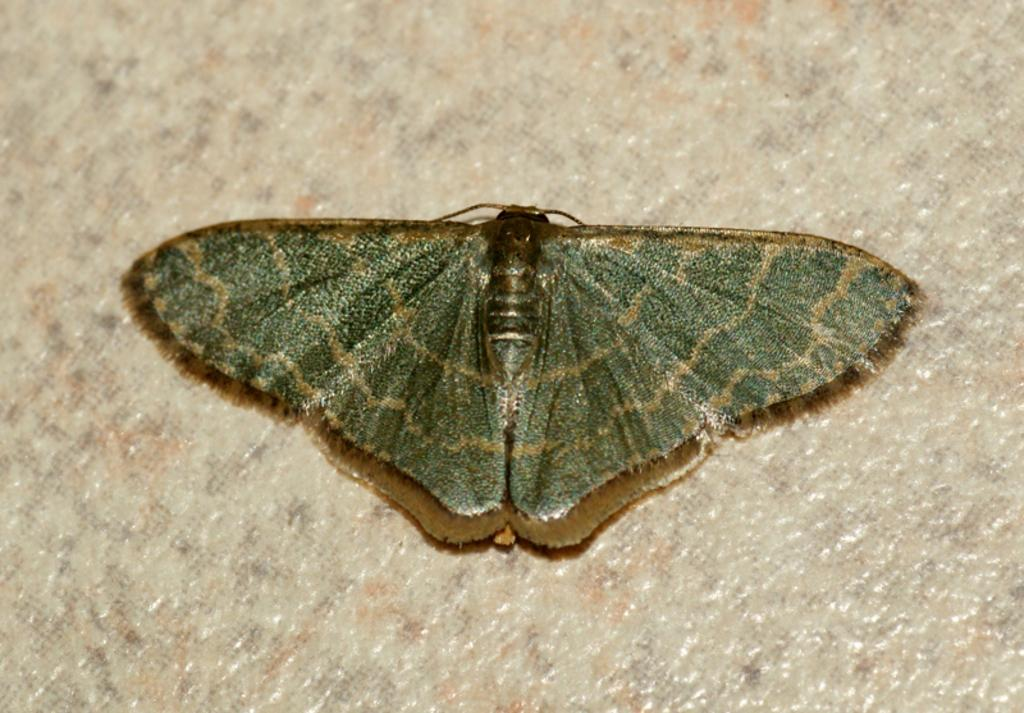What is the main subject of the image? There is a butterfly in the image. Where is the butterfly located in the image? The butterfly is in the center of the image. What type of good-bye message is written on the maid's apron in the image? There is no maid or good-bye message present in the image; it features a butterfly in the center. How many pigs are visible in the image? There are no pigs present in the image; it features a butterfly in the center. 